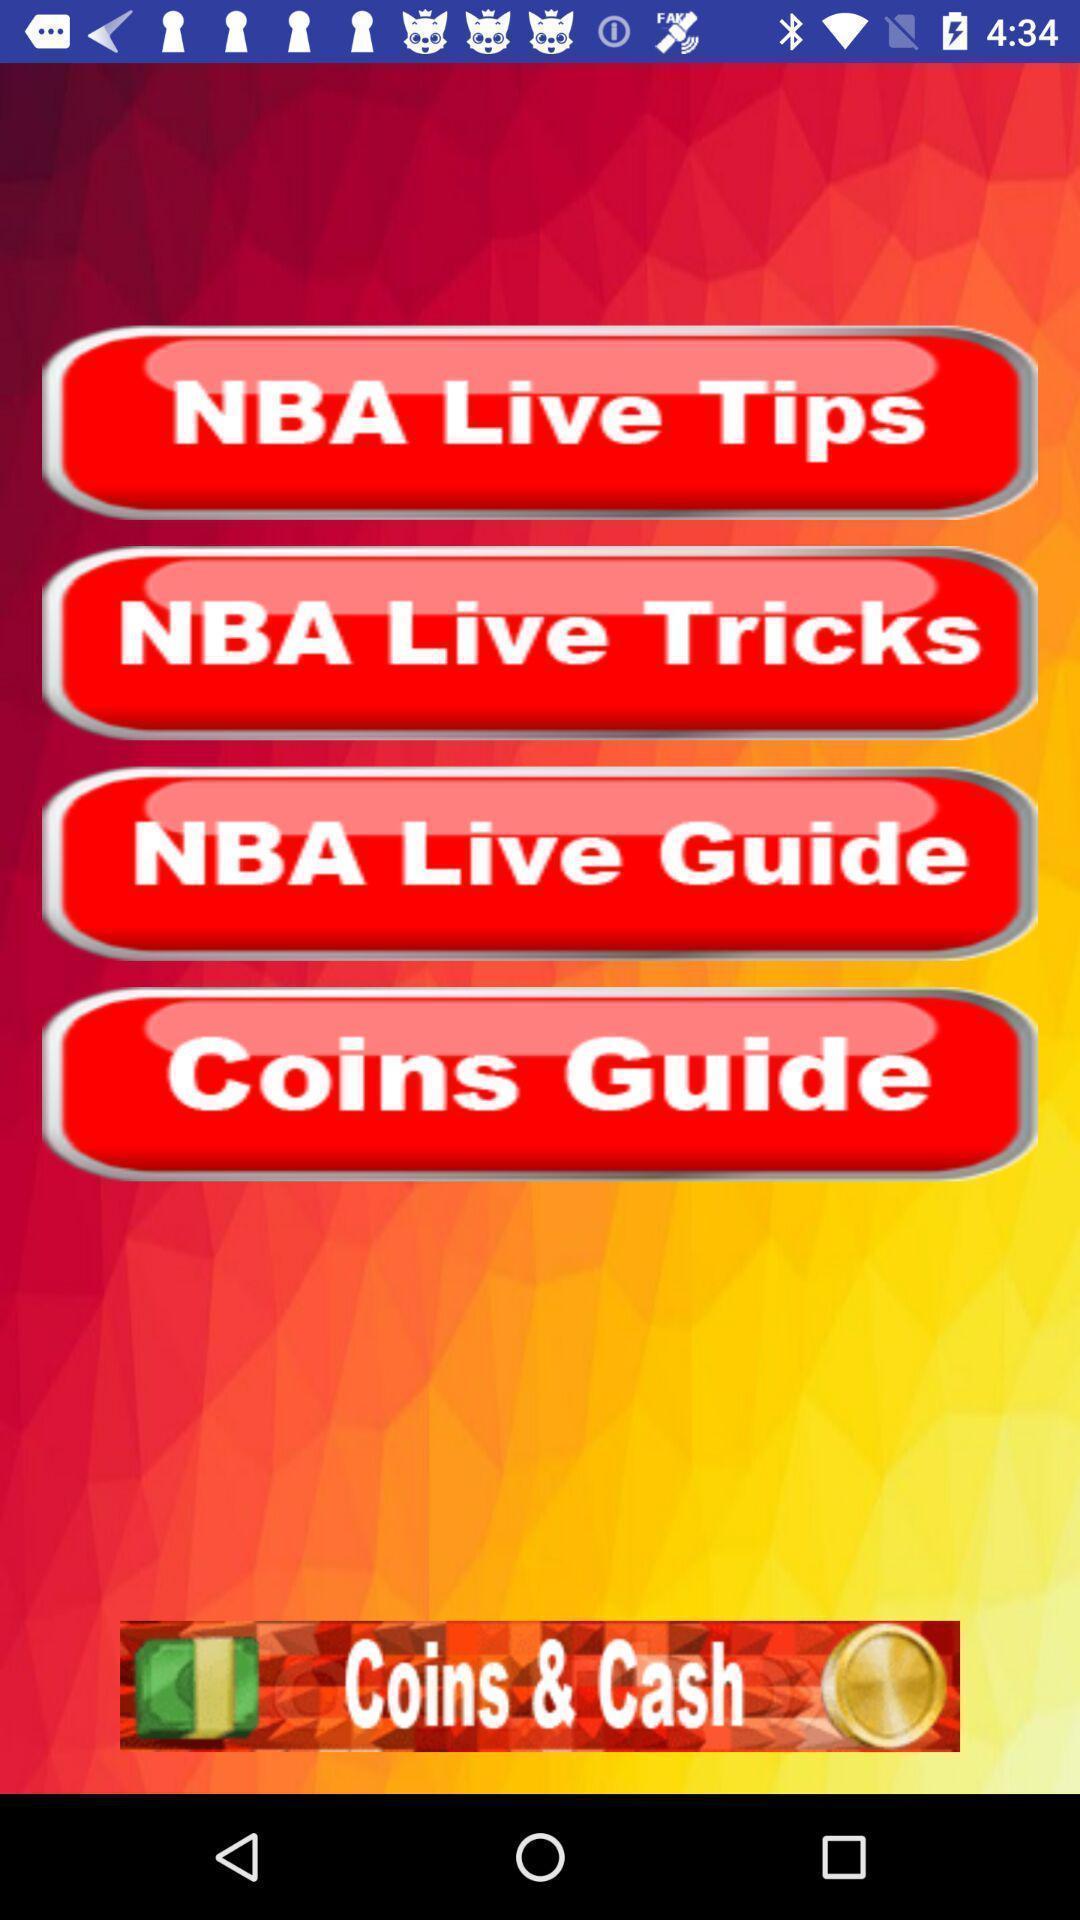Provide a detailed account of this screenshot. Screen shows a live tricks application. 